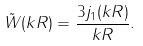Convert formula to latex. <formula><loc_0><loc_0><loc_500><loc_500>\tilde { W } ( k R ) = \frac { 3 j _ { 1 } ( k R ) } { k R } .</formula> 